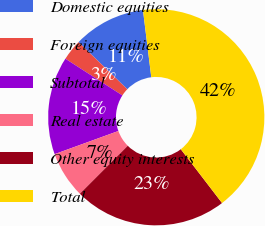Convert chart to OTSL. <chart><loc_0><loc_0><loc_500><loc_500><pie_chart><fcel>Domestic equities<fcel>Foreign equities<fcel>Subtotal<fcel>Real estate<fcel>Other equity interests<fcel>Total<nl><fcel>10.81%<fcel>3.12%<fcel>14.65%<fcel>6.97%<fcel>22.9%<fcel>41.55%<nl></chart> 